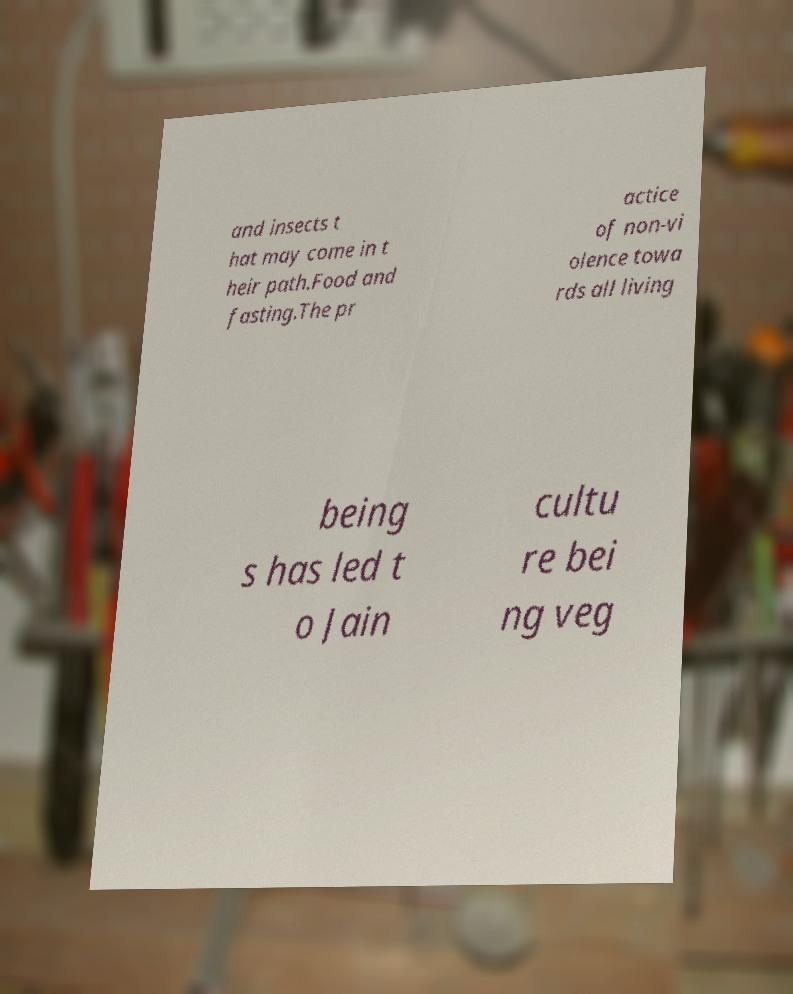Can you accurately transcribe the text from the provided image for me? and insects t hat may come in t heir path.Food and fasting.The pr actice of non-vi olence towa rds all living being s has led t o Jain cultu re bei ng veg 